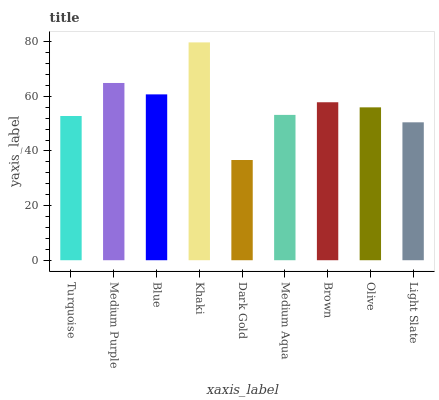Is Dark Gold the minimum?
Answer yes or no. Yes. Is Khaki the maximum?
Answer yes or no. Yes. Is Medium Purple the minimum?
Answer yes or no. No. Is Medium Purple the maximum?
Answer yes or no. No. Is Medium Purple greater than Turquoise?
Answer yes or no. Yes. Is Turquoise less than Medium Purple?
Answer yes or no. Yes. Is Turquoise greater than Medium Purple?
Answer yes or no. No. Is Medium Purple less than Turquoise?
Answer yes or no. No. Is Olive the high median?
Answer yes or no. Yes. Is Olive the low median?
Answer yes or no. Yes. Is Dark Gold the high median?
Answer yes or no. No. Is Brown the low median?
Answer yes or no. No. 